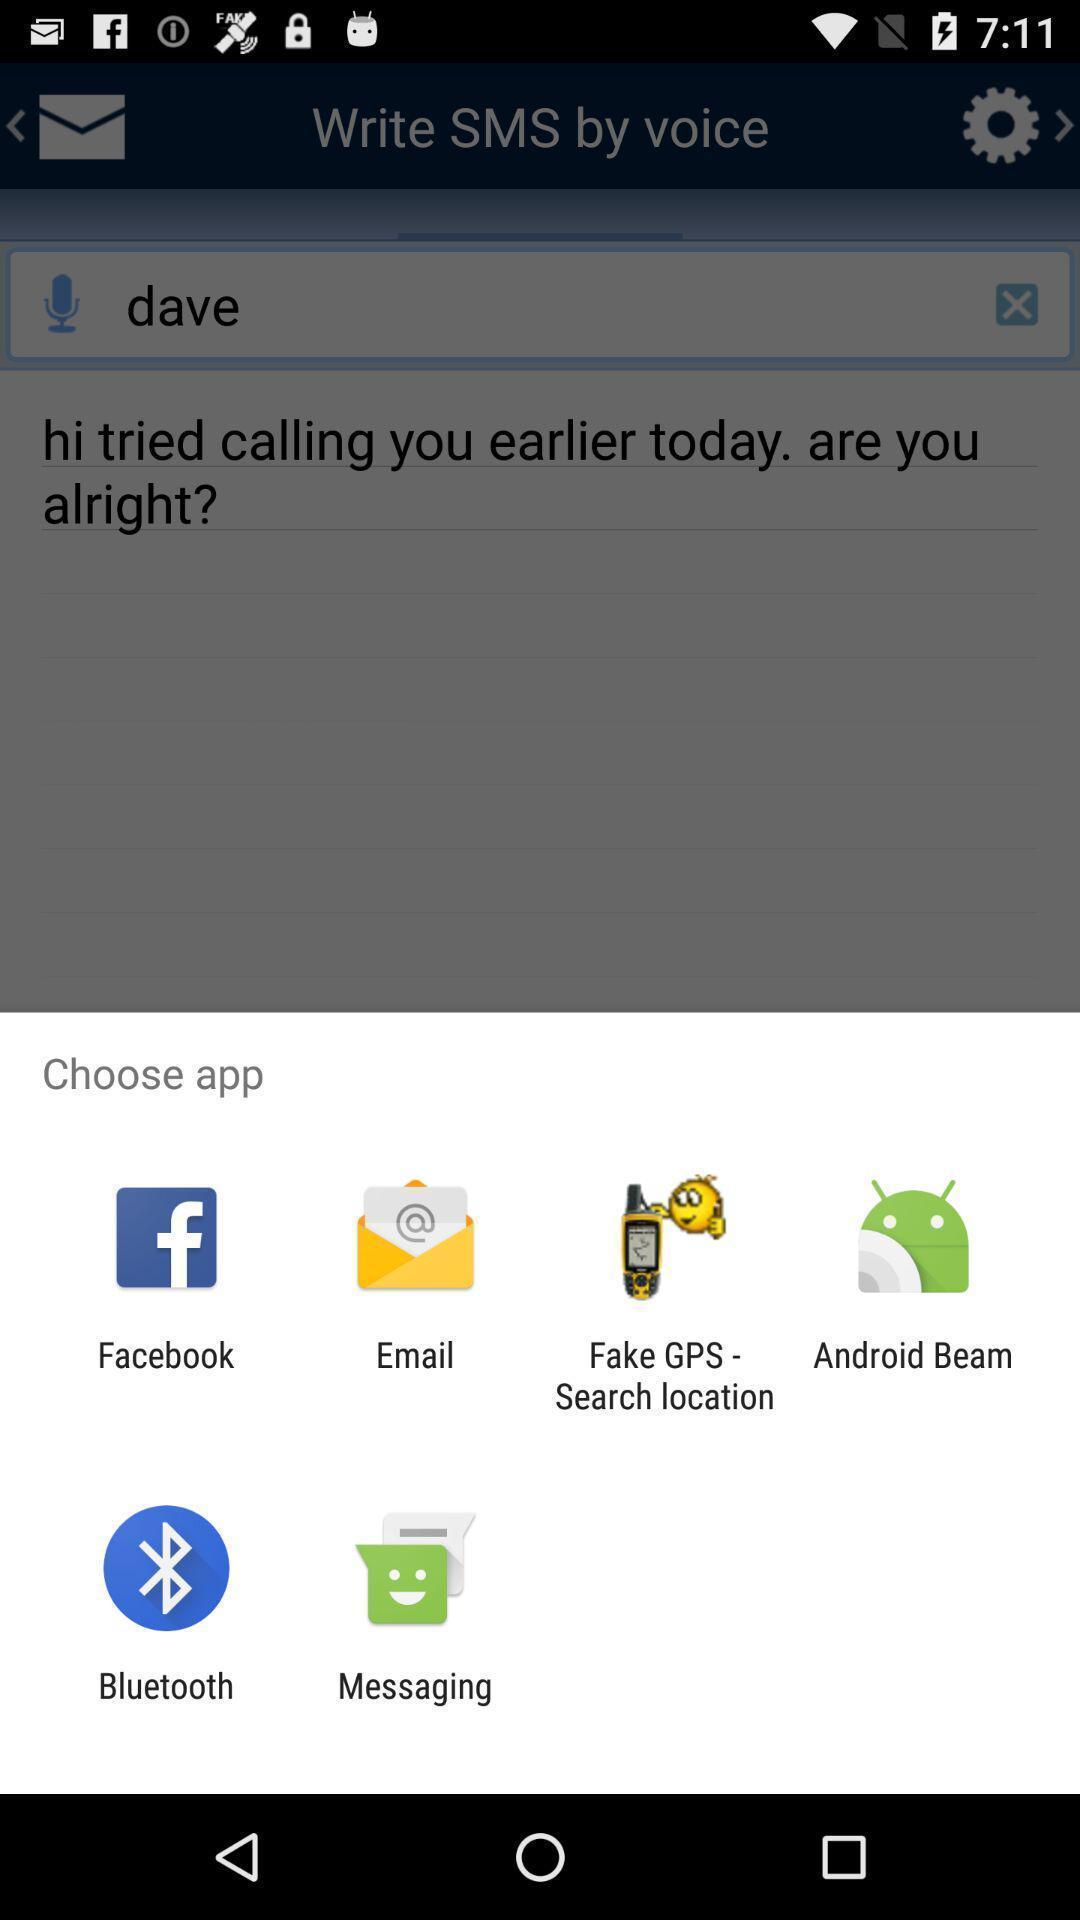Describe the content in this image. Push up page showing app preference to share. 